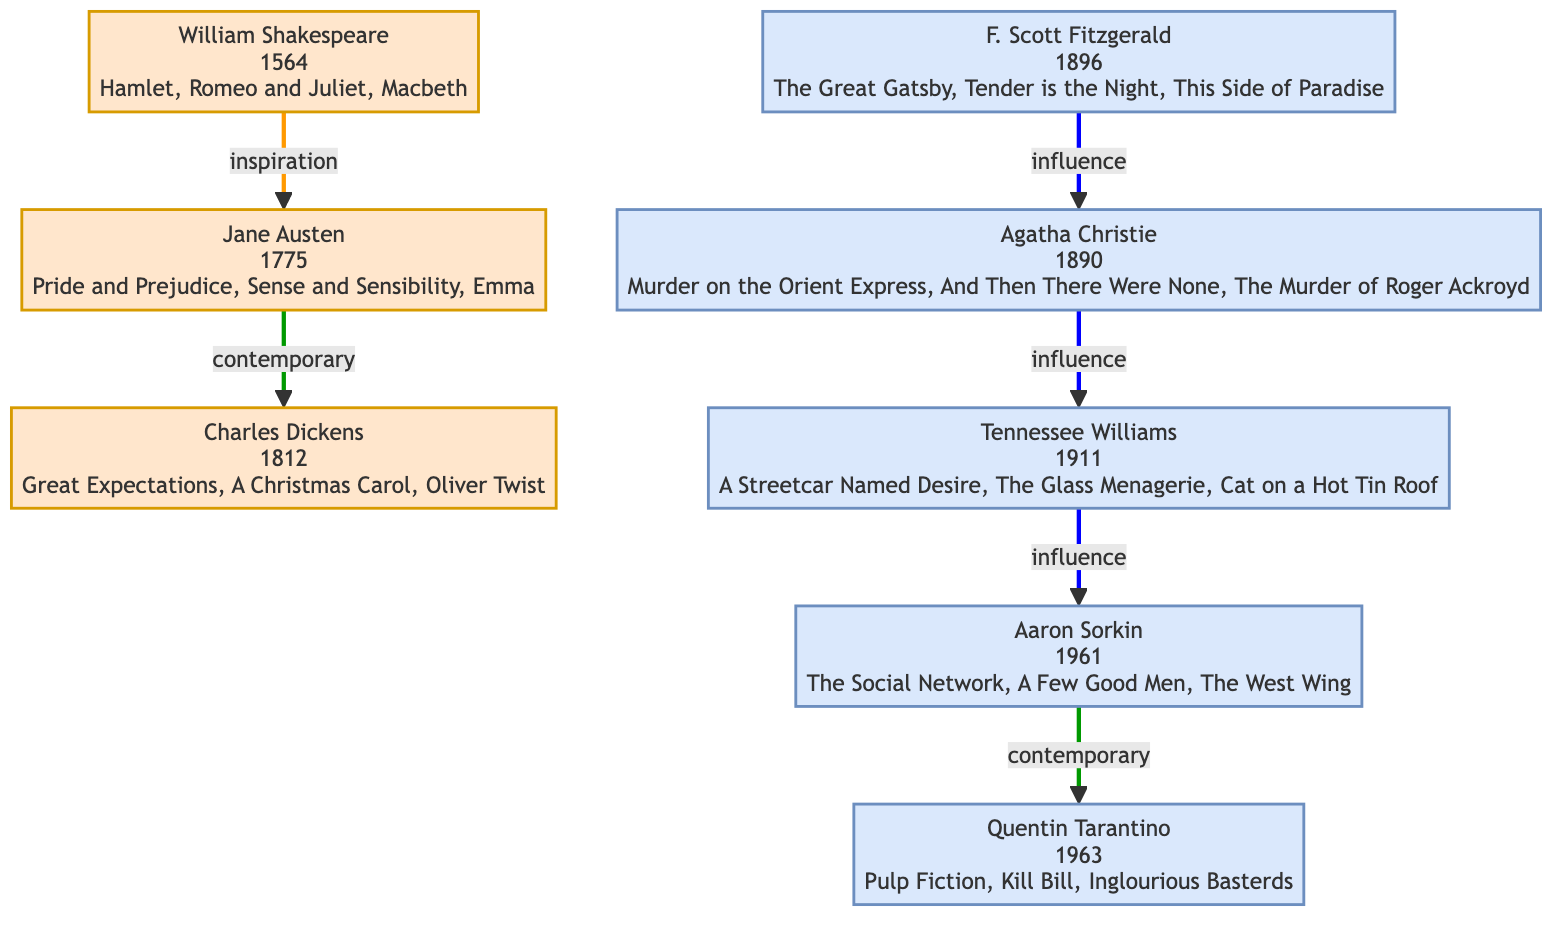What is the birth year of William Shakespeare? The diagram lists the birth year of William Shakespeare next to his name, which is 1564. Therefore, the answer can be found directly in the node corresponding to William Shakespeare.
Answer: 1564 How many masterworks did Agatha Christie create? Agatha Christie's node shows a total of three masterpieces: "Murder on the Orient Express," "And Then There Were None," and "The Murder of Roger Ackroyd." Hence, counting these, we find she created three notable works.
Answer: 3 What relationship exists between Quentin Tarantino and Aaron Sorkin? The diagram indicates a line connecting Quentin Tarantino and Aaron Sorkin labeled "contemporary." This shows they belong to the same period in the family tree.
Answer: contemporary Who is depicted as the influence of Tennessee Williams? Referring to the diagram, the connection from Tennessee Williams leads to Aaron Sorkin, marked as "influence." This indicates that Tennessee Williams had a significant impression on the works of Aaron Sorkin.
Answer: Aaron Sorkin Which two screenwriters are contemporaries according to the diagram? Looking for connections labeled "contemporary," we can see that Jane Austen and Charles Dickens are connected this way. There is another connection that applies to Aaron Sorkin and Quentin Tarantino as well. So, the two pairs indicate who can be termed contemporaries.
Answer: Jane Austen and Charles Dickens; Aaron Sorkin and Quentin Tarantino What node comes after Jane Austen when considering the influence trajectory? As we analyze the connections, Jane Austen is indicated to connect to Charles Dickens, who is shown as a contemporary. Hence, if we follow the influence path directly from Jane Austen, we reach his node next.
Answer: Charles Dickens How many edges are there in total in the diagram? To find the total number of edges, we can count lines connecting the nodes in the diagram. Upon inspection, there are six edges connecting various screenwriters, reflecting their relationships indicated.
Answer: 6 Which writer's works were influenced by Agatha Christie? From the diagram, a direct influence connection exists between Agatha Christie and Tennessee Williams, showing that Agatha Christie's creations played a role in impacting his work.
Answer: Tennessee Williams Which writer wrote "The Great Gatsby"? The diagram specifies that "The Great Gatsby" is one of the masterworks associated with F. Scott Fitzgerald, confirming his contribution to literary art.
Answer: F. Scott Fitzgerald 